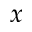Convert formula to latex. <formula><loc_0><loc_0><loc_500><loc_500>x</formula> 